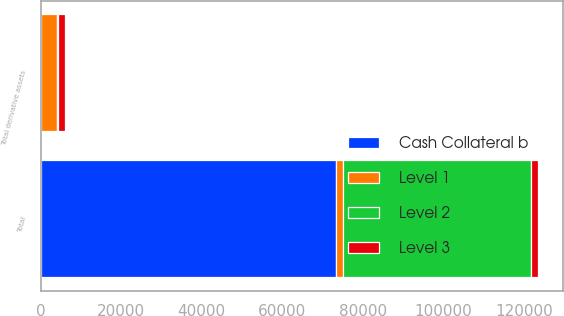Convert chart to OTSL. <chart><loc_0><loc_0><loc_500><loc_500><stacked_bar_chart><ecel><fcel>Total derivative assets<fcel>Total<nl><fcel>Cash Collateral b<fcel>165<fcel>73301<nl><fcel>Level 1<fcel>3875<fcel>1734<nl><fcel>Level 2<fcel>179<fcel>46726<nl><fcel>Level 3<fcel>1734<fcel>1734<nl></chart> 